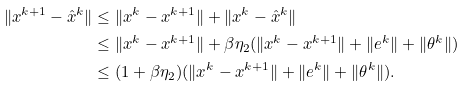<formula> <loc_0><loc_0><loc_500><loc_500>\| x ^ { k + 1 } - \hat { x } ^ { k } \| & \leq \| x ^ { k } - x ^ { k + 1 } \| + \| x ^ { k } - \hat { x } ^ { k } \| \\ & \leq \| x ^ { k } - x ^ { k + 1 } \| + \beta \eta _ { 2 } ( \| x ^ { k } - x ^ { k + 1 } \| + \| e ^ { k } \| + \| \theta ^ { k } \| ) \\ & \leq ( 1 + \beta \eta _ { 2 } ) ( \| x ^ { k } - x ^ { k + 1 } \| + \| e ^ { k } \| + \| \theta ^ { k } \| ) .</formula> 